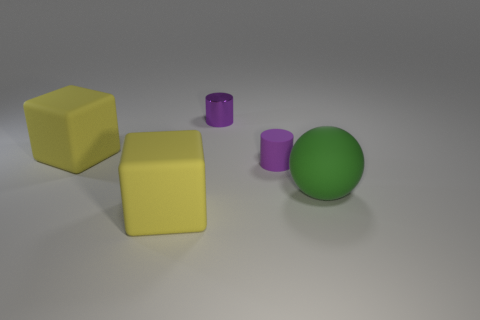Add 1 tiny green blocks. How many objects exist? 6 Subtract all cylinders. How many objects are left? 3 Add 3 large yellow things. How many large yellow things exist? 5 Subtract 0 gray cylinders. How many objects are left? 5 Subtract all balls. Subtract all small purple objects. How many objects are left? 2 Add 3 large yellow things. How many large yellow things are left? 5 